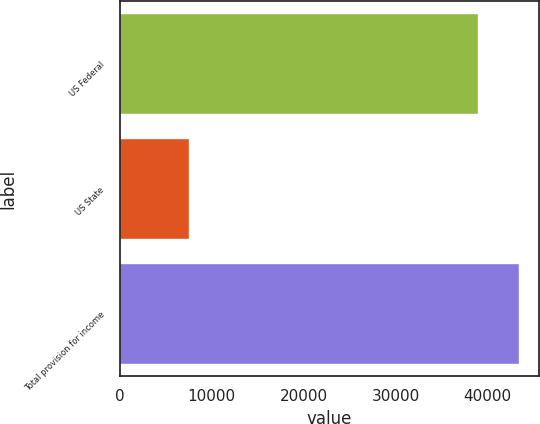Convert chart to OTSL. <chart><loc_0><loc_0><loc_500><loc_500><bar_chart><fcel>US Federal<fcel>US State<fcel>Total provision for income<nl><fcel>38916<fcel>7547<fcel>43439<nl></chart> 